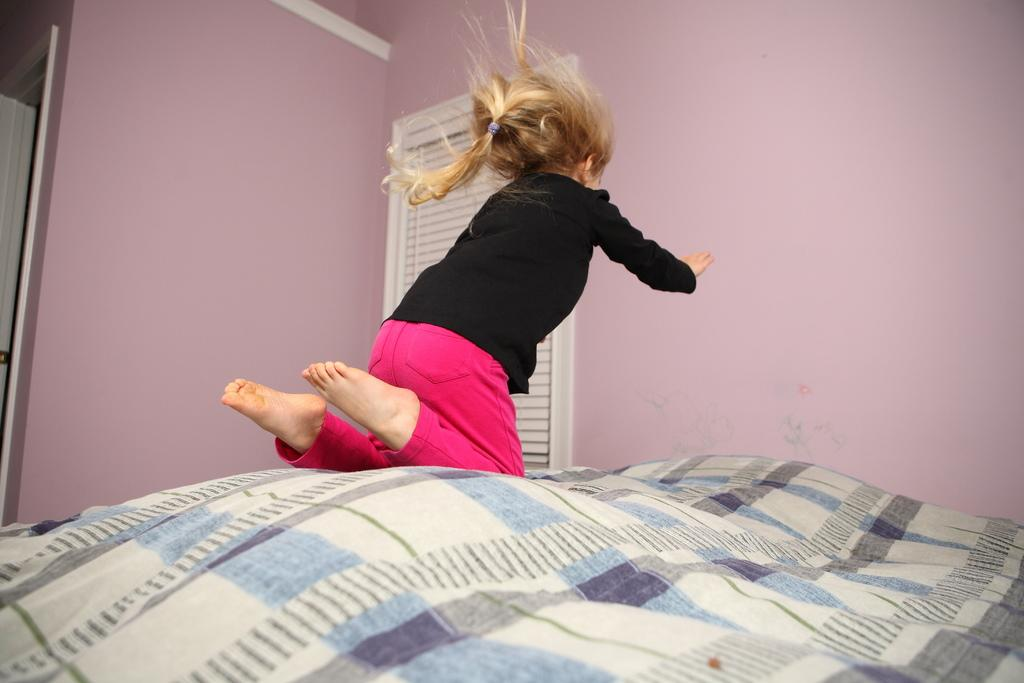What is the woman in the image doing? The woman is jumping onto the bed. What is the woman wearing on her upper body? The woman is wearing a black shirt. What is the woman wearing on her lower body? The woman is wearing pink pants. What can be seen beside the bed in the image? There is a window beside the bed. What is the color of the wall in the image? The color of the wall is pale pink. What type of toy is the woman using to control the slave in the image? There is no toy, control, or slave present in the image; it features a woman jumping onto a bed. 